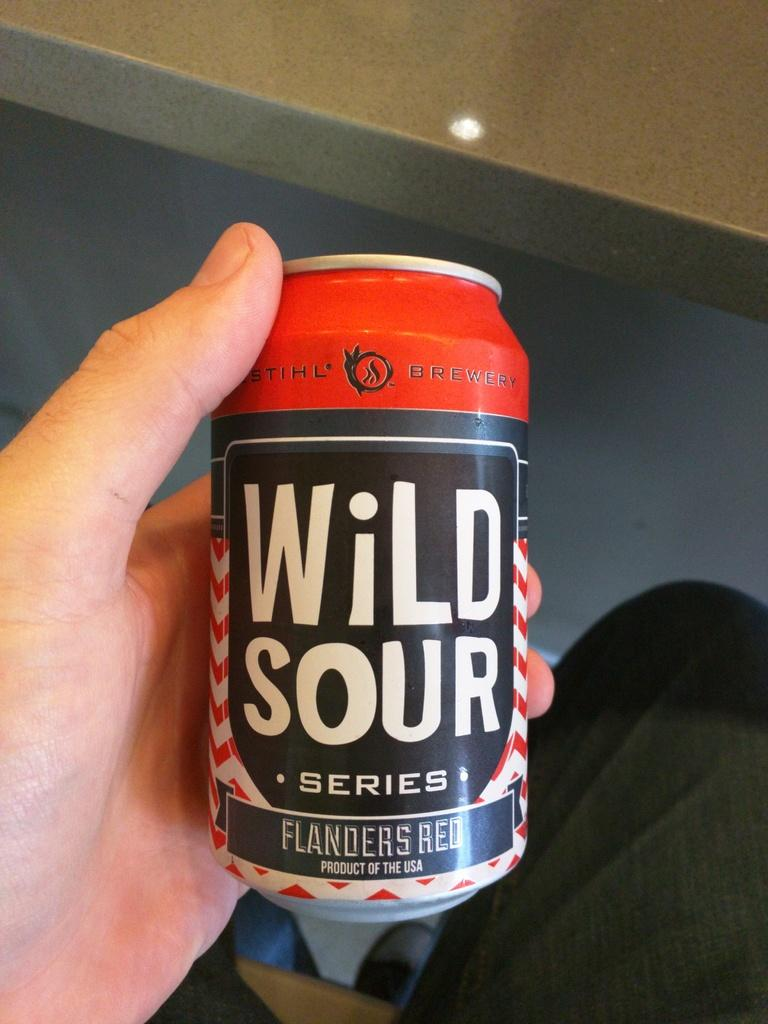Provide a one-sentence caption for the provided image. You see a hand holding a can of beer from the Wild Sour series. 